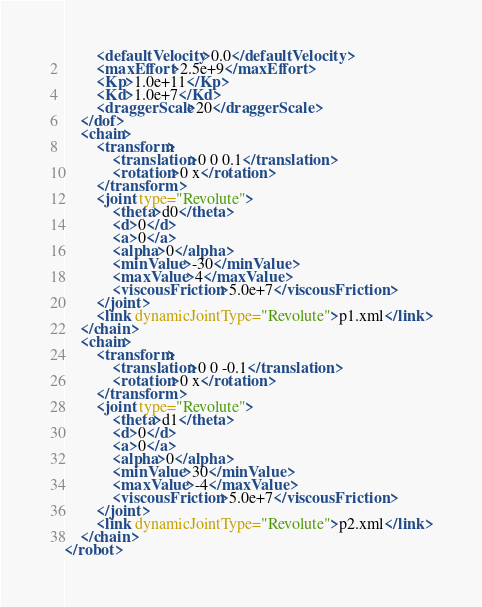Convert code to text. <code><loc_0><loc_0><loc_500><loc_500><_XML_>        <defaultVelocity>0.0</defaultVelocity>
        <maxEffort>2.5e+9</maxEffort>
        <Kp>1.0e+11</Kp>
        <Kd>1.0e+7</Kd>
        <draggerScale>20</draggerScale>
    </dof>
    <chain>
        <transform>
            <translation>0 0 0.1</translation>
            <rotation>0 x</rotation>
        </transform>
        <joint type="Revolute">
            <theta>d0</theta>
            <d>0</d>
            <a>0</a>
            <alpha>0</alpha>
            <minValue>-30</minValue>
            <maxValue>4</maxValue>
            <viscousFriction>5.0e+7</viscousFriction>
        </joint>
        <link dynamicJointType="Revolute">p1.xml</link>
    </chain>
    <chain>
        <transform>
            <translation>0 0 -0.1</translation>
            <rotation>0 x</rotation>
        </transform>
        <joint type="Revolute">
            <theta>d1</theta>
            <d>0</d>
            <a>0</a>
            <alpha>0</alpha>
            <minValue>30</minValue>
            <maxValue>-4</maxValue>
            <viscousFriction>5.0e+7</viscousFriction>
        </joint>
        <link dynamicJointType="Revolute">p2.xml</link>
    </chain>
</robot>
</code> 